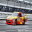When observing the details of the race car in the image, can you discuss specifically about its aerodynamic features that distinguish it from regular vehicles? Certainly! The race car in the image is equipped with several aerodynamic features designed to reduce air resistance and increase downforce. Notice the low and wide stance, which minimizes the amount of air flowing underneath the vehicle, reducing lift and increasing stability at high speeds. The front spoiler, or splitter, along with the rear wing, helps in generating additional downforce. These components channel air in a manner that presses the car down onto the track, enhancing traction and allowing for faster cornering. Such features are crucial in motorsport but are generally not present in regular vehicles, as they prioritize fuel efficiency and comfort over extreme speed and handling. 